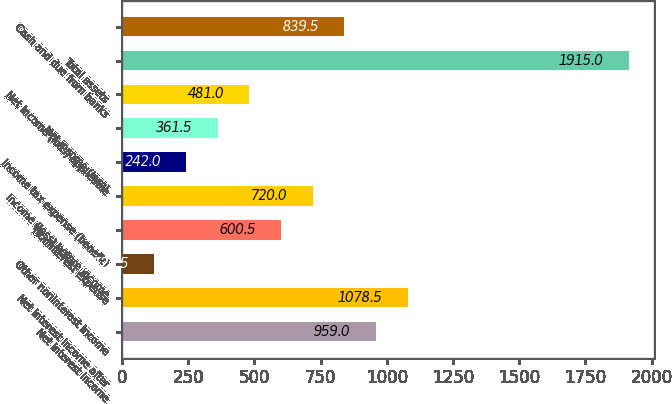<chart> <loc_0><loc_0><loc_500><loc_500><bar_chart><fcel>Net interest income<fcel>Net interest income after<fcel>Other noninterest income<fcel>Noninterest expense<fcel>Income (loss) before income<fcel>Income tax expense (benefit)<fcel>Net income (loss)<fcel>Net income (loss) applicable<fcel>Total assets<fcel>Cash and due from banks<nl><fcel>959<fcel>1078.5<fcel>122.5<fcel>600.5<fcel>720<fcel>242<fcel>361.5<fcel>481<fcel>1915<fcel>839.5<nl></chart> 